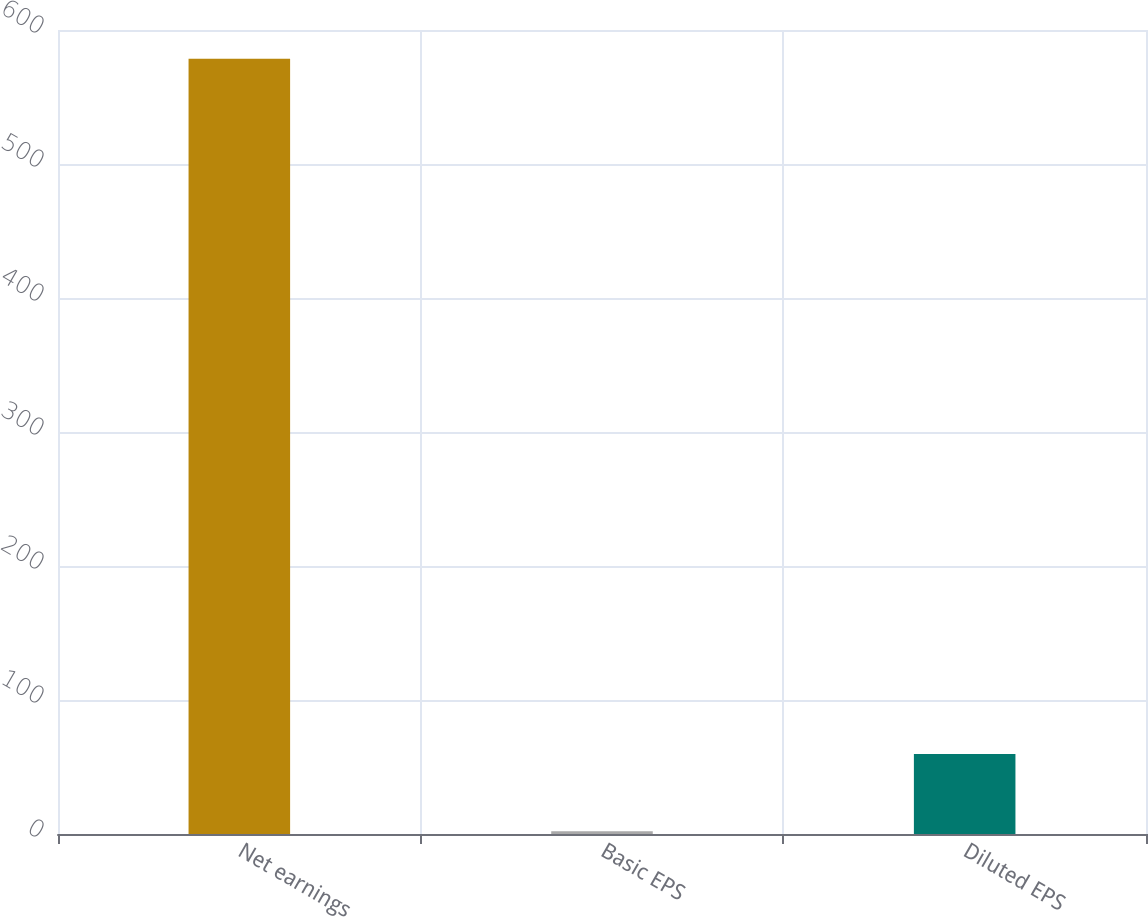Convert chart. <chart><loc_0><loc_0><loc_500><loc_500><bar_chart><fcel>Net earnings<fcel>Basic EPS<fcel>Diluted EPS<nl><fcel>578.6<fcel>2.01<fcel>59.67<nl></chart> 